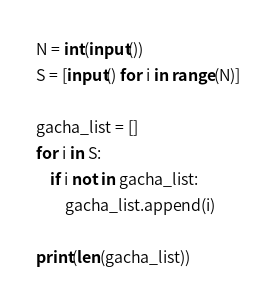<code> <loc_0><loc_0><loc_500><loc_500><_Python_>N = int(input())
S = [input() for i in range(N)]

gacha_list = []
for i in S:
    if i not in gacha_list:
        gacha_list.append(i)

print(len(gacha_list))</code> 